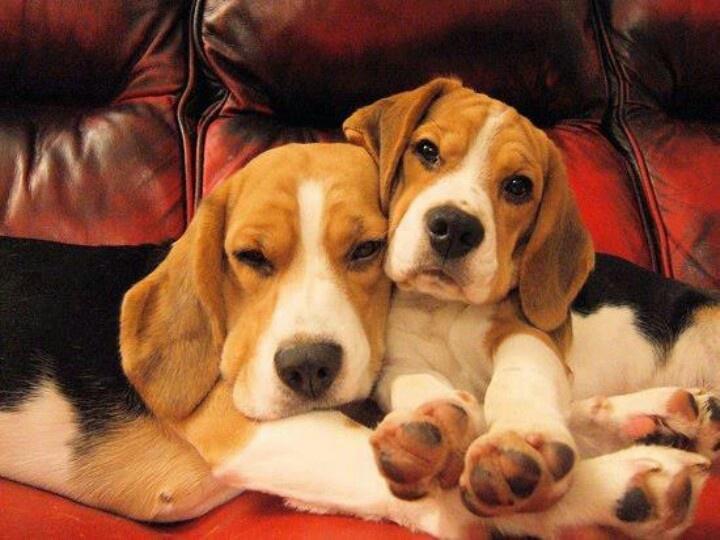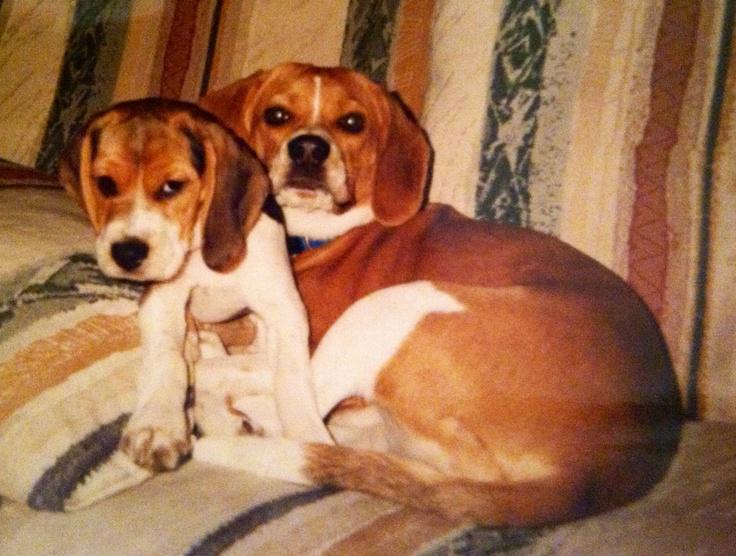The first image is the image on the left, the second image is the image on the right. Assess this claim about the two images: "A total of four beagles are shown, and at least one beagle is posed on an upholstered seat.". Correct or not? Answer yes or no. Yes. The first image is the image on the left, the second image is the image on the right. Examine the images to the left and right. Is the description "There is exactly two dogs in the right image." accurate? Answer yes or no. Yes. 